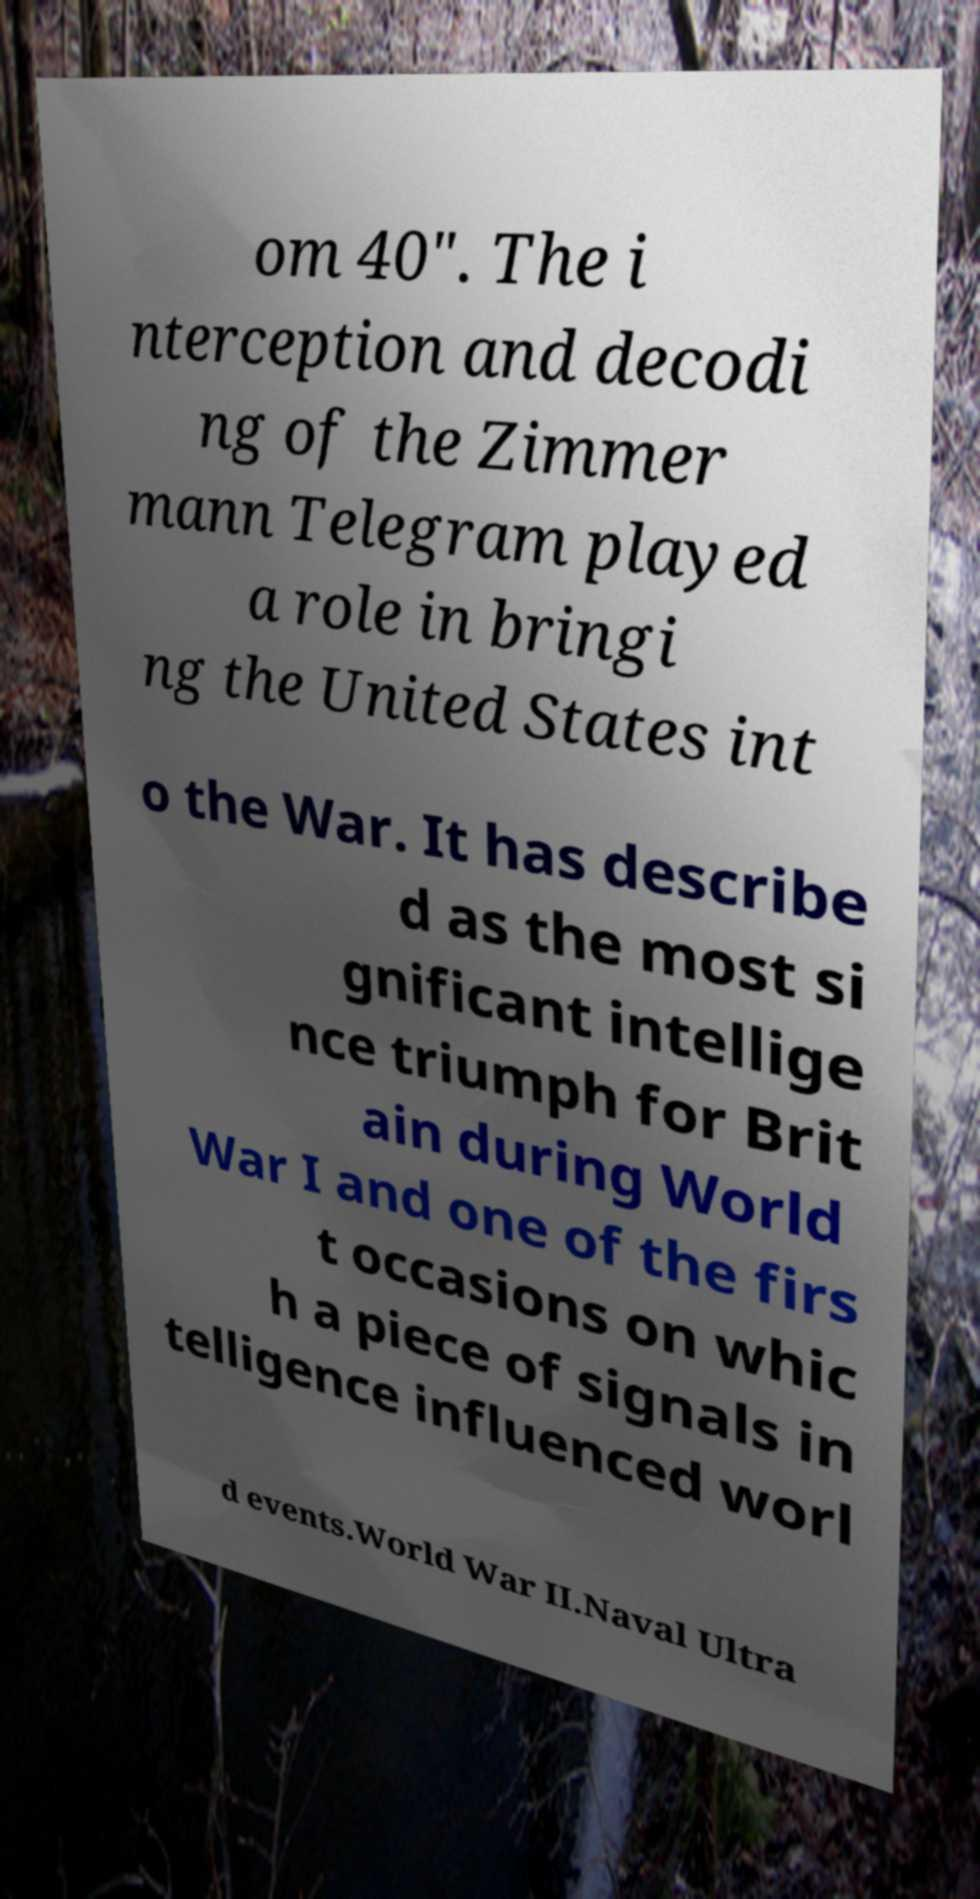What messages or text are displayed in this image? I need them in a readable, typed format. om 40". The i nterception and decodi ng of the Zimmer mann Telegram played a role in bringi ng the United States int o the War. It has describe d as the most si gnificant intellige nce triumph for Brit ain during World War I and one of the firs t occasions on whic h a piece of signals in telligence influenced worl d events.World War II.Naval Ultra 